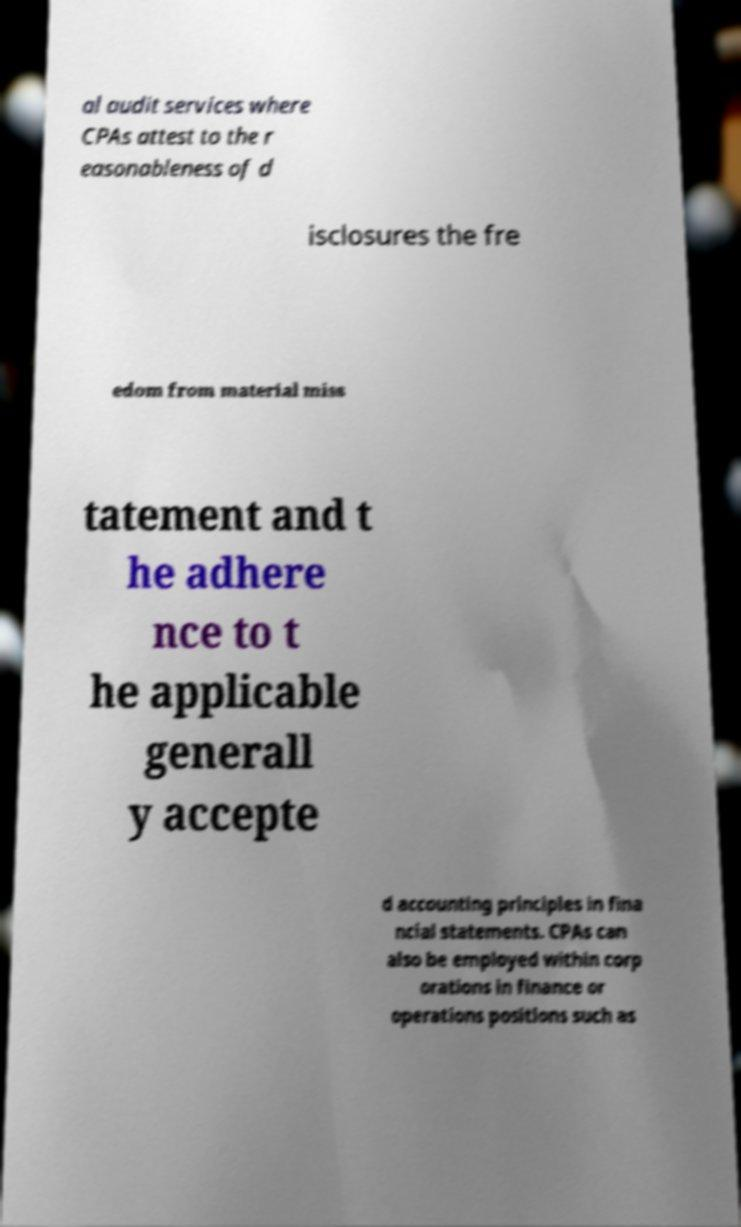What messages or text are displayed in this image? I need them in a readable, typed format. al audit services where CPAs attest to the r easonableness of d isclosures the fre edom from material miss tatement and t he adhere nce to t he applicable generall y accepte d accounting principles in fina ncial statements. CPAs can also be employed within corp orations in finance or operations positions such as 